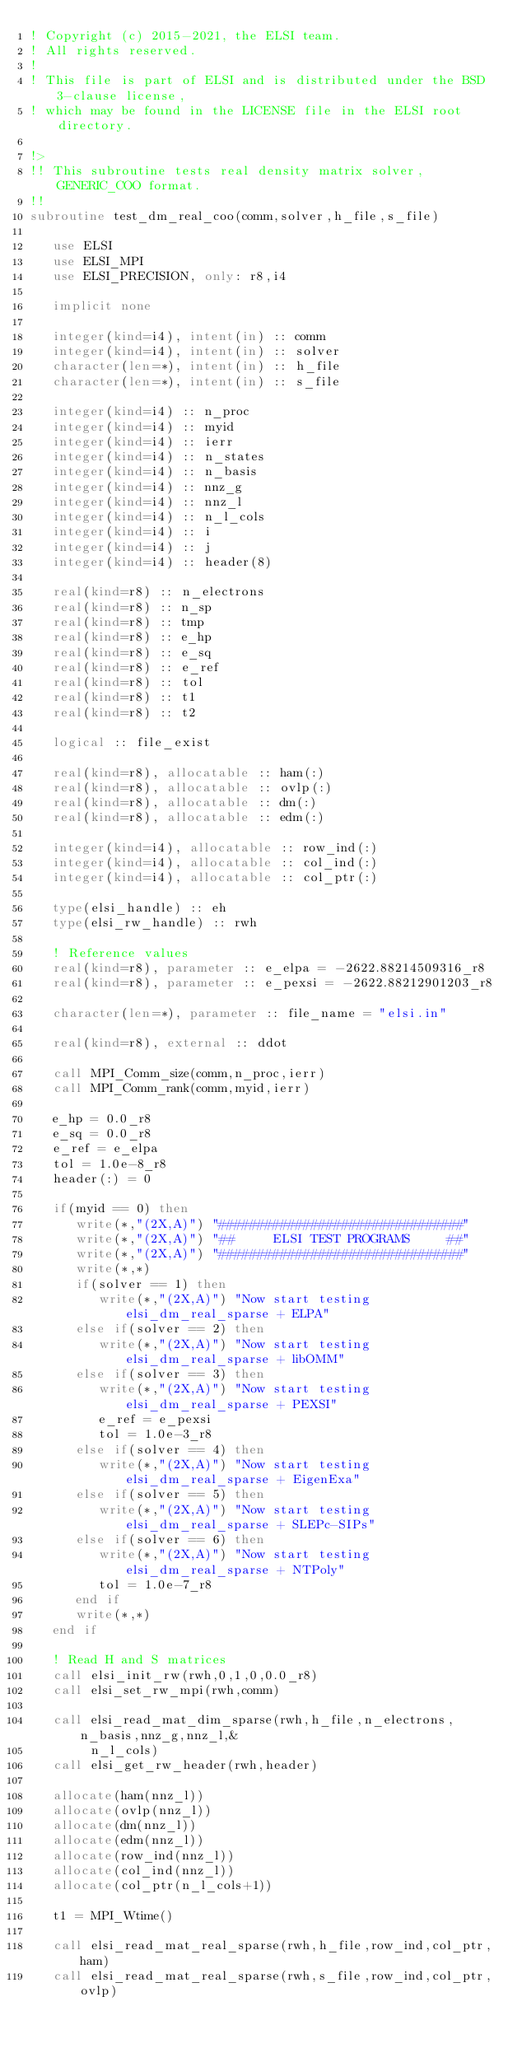<code> <loc_0><loc_0><loc_500><loc_500><_FORTRAN_>! Copyright (c) 2015-2021, the ELSI team.
! All rights reserved.
!
! This file is part of ELSI and is distributed under the BSD 3-clause license,
! which may be found in the LICENSE file in the ELSI root directory.

!>
!! This subroutine tests real density matrix solver, GENERIC_COO format.
!!
subroutine test_dm_real_coo(comm,solver,h_file,s_file)

   use ELSI
   use ELSI_MPI
   use ELSI_PRECISION, only: r8,i4

   implicit none

   integer(kind=i4), intent(in) :: comm
   integer(kind=i4), intent(in) :: solver
   character(len=*), intent(in) :: h_file
   character(len=*), intent(in) :: s_file

   integer(kind=i4) :: n_proc
   integer(kind=i4) :: myid
   integer(kind=i4) :: ierr
   integer(kind=i4) :: n_states
   integer(kind=i4) :: n_basis
   integer(kind=i4) :: nnz_g
   integer(kind=i4) :: nnz_l
   integer(kind=i4) :: n_l_cols
   integer(kind=i4) :: i
   integer(kind=i4) :: j
   integer(kind=i4) :: header(8)

   real(kind=r8) :: n_electrons
   real(kind=r8) :: n_sp
   real(kind=r8) :: tmp
   real(kind=r8) :: e_hp
   real(kind=r8) :: e_sq
   real(kind=r8) :: e_ref
   real(kind=r8) :: tol
   real(kind=r8) :: t1
   real(kind=r8) :: t2

   logical :: file_exist

   real(kind=r8), allocatable :: ham(:)
   real(kind=r8), allocatable :: ovlp(:)
   real(kind=r8), allocatable :: dm(:)
   real(kind=r8), allocatable :: edm(:)

   integer(kind=i4), allocatable :: row_ind(:)
   integer(kind=i4), allocatable :: col_ind(:)
   integer(kind=i4), allocatable :: col_ptr(:)

   type(elsi_handle) :: eh
   type(elsi_rw_handle) :: rwh

   ! Reference values
   real(kind=r8), parameter :: e_elpa = -2622.88214509316_r8
   real(kind=r8), parameter :: e_pexsi = -2622.88212901203_r8

   character(len=*), parameter :: file_name = "elsi.in"

   real(kind=r8), external :: ddot

   call MPI_Comm_size(comm,n_proc,ierr)
   call MPI_Comm_rank(comm,myid,ierr)

   e_hp = 0.0_r8
   e_sq = 0.0_r8
   e_ref = e_elpa
   tol = 1.0e-8_r8
   header(:) = 0

   if(myid == 0) then
      write(*,"(2X,A)") "################################"
      write(*,"(2X,A)") "##     ELSI TEST PROGRAMS     ##"
      write(*,"(2X,A)") "################################"
      write(*,*)
      if(solver == 1) then
         write(*,"(2X,A)") "Now start testing  elsi_dm_real_sparse + ELPA"
      else if(solver == 2) then
         write(*,"(2X,A)") "Now start testing  elsi_dm_real_sparse + libOMM"
      else if(solver == 3) then
         write(*,"(2X,A)") "Now start testing  elsi_dm_real_sparse + PEXSI"
         e_ref = e_pexsi
         tol = 1.0e-3_r8
      else if(solver == 4) then
         write(*,"(2X,A)") "Now start testing  elsi_dm_real_sparse + EigenExa"
      else if(solver == 5) then
         write(*,"(2X,A)") "Now start testing  elsi_dm_real_sparse + SLEPc-SIPs"
      else if(solver == 6) then
         write(*,"(2X,A)") "Now start testing  elsi_dm_real_sparse + NTPoly"
         tol = 1.0e-7_r8
      end if
      write(*,*)
   end if

   ! Read H and S matrices
   call elsi_init_rw(rwh,0,1,0,0.0_r8)
   call elsi_set_rw_mpi(rwh,comm)

   call elsi_read_mat_dim_sparse(rwh,h_file,n_electrons,n_basis,nnz_g,nnz_l,&
        n_l_cols)
   call elsi_get_rw_header(rwh,header)

   allocate(ham(nnz_l))
   allocate(ovlp(nnz_l))
   allocate(dm(nnz_l))
   allocate(edm(nnz_l))
   allocate(row_ind(nnz_l))
   allocate(col_ind(nnz_l))
   allocate(col_ptr(n_l_cols+1))

   t1 = MPI_Wtime()

   call elsi_read_mat_real_sparse(rwh,h_file,row_ind,col_ptr,ham)
   call elsi_read_mat_real_sparse(rwh,s_file,row_ind,col_ptr,ovlp)
</code> 